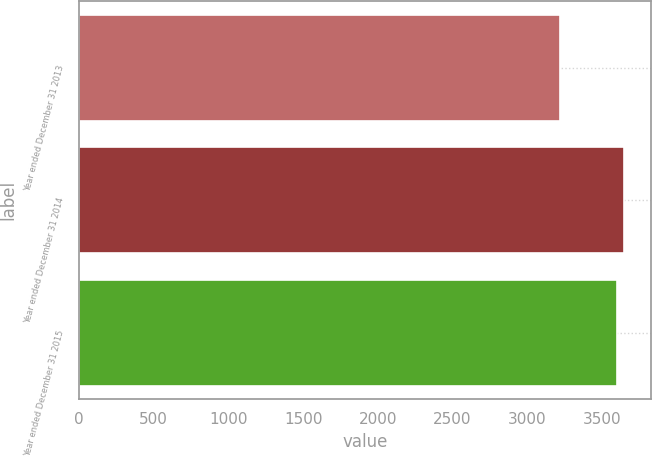<chart> <loc_0><loc_0><loc_500><loc_500><bar_chart><fcel>Year ended December 31 2013<fcel>Year ended December 31 2014<fcel>Year ended December 31 2015<nl><fcel>3216<fcel>3646<fcel>3598<nl></chart> 